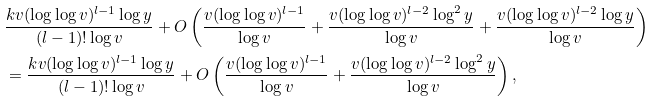Convert formula to latex. <formula><loc_0><loc_0><loc_500><loc_500>& \frac { k v ( \log \log v ) ^ { l - 1 } \log y } { ( l - 1 ) ! \log v } + O \left ( \frac { v ( \log \log v ) ^ { l - 1 } } { \log v } + \frac { v ( \log \log v ) ^ { l - 2 } \log ^ { 2 } y } { \log v } + \frac { v ( \log \log v ) ^ { l - 2 } \log y } { \log v } \right ) \\ & = \frac { k v ( \log \log v ) ^ { l - 1 } \log y } { ( l - 1 ) ! \log v } + O \left ( \frac { v ( \log \log v ) ^ { l - 1 } } { \log v } + \frac { v ( \log \log v ) ^ { l - 2 } \log ^ { 2 } y } { \log v } \right ) ,</formula> 